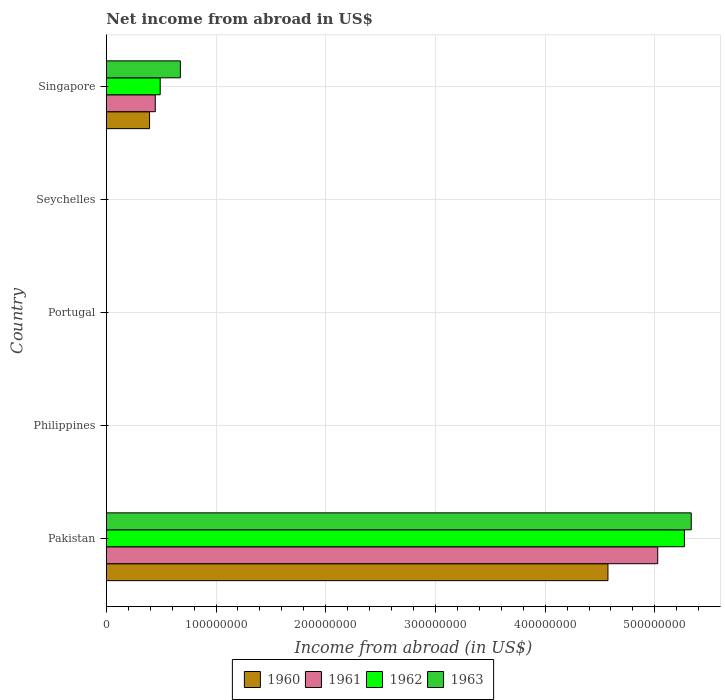Are the number of bars on each tick of the Y-axis equal?
Offer a very short reply. No. How many bars are there on the 4th tick from the top?
Ensure brevity in your answer.  0. What is the net income from abroad in 1962 in Seychelles?
Provide a succinct answer. 0. Across all countries, what is the maximum net income from abroad in 1963?
Your answer should be compact. 5.33e+08. Across all countries, what is the minimum net income from abroad in 1960?
Keep it short and to the point. 0. In which country was the net income from abroad in 1962 maximum?
Offer a very short reply. Pakistan. What is the total net income from abroad in 1961 in the graph?
Offer a very short reply. 5.47e+08. What is the average net income from abroad in 1961 per country?
Ensure brevity in your answer.  1.09e+08. What is the difference between the net income from abroad in 1960 and net income from abroad in 1962 in Pakistan?
Offer a terse response. -6.97e+07. What is the difference between the highest and the lowest net income from abroad in 1961?
Offer a very short reply. 5.03e+08. In how many countries, is the net income from abroad in 1961 greater than the average net income from abroad in 1961 taken over all countries?
Ensure brevity in your answer.  1. Is it the case that in every country, the sum of the net income from abroad in 1963 and net income from abroad in 1960 is greater than the sum of net income from abroad in 1962 and net income from abroad in 1961?
Make the answer very short. No. Is it the case that in every country, the sum of the net income from abroad in 1961 and net income from abroad in 1962 is greater than the net income from abroad in 1963?
Your answer should be compact. No. How many bars are there?
Provide a short and direct response. 8. Are all the bars in the graph horizontal?
Provide a short and direct response. Yes. What is the difference between two consecutive major ticks on the X-axis?
Offer a terse response. 1.00e+08. Does the graph contain any zero values?
Ensure brevity in your answer.  Yes. Does the graph contain grids?
Your response must be concise. Yes. Where does the legend appear in the graph?
Give a very brief answer. Bottom center. How are the legend labels stacked?
Offer a terse response. Horizontal. What is the title of the graph?
Give a very brief answer. Net income from abroad in US$. Does "1971" appear as one of the legend labels in the graph?
Your response must be concise. No. What is the label or title of the X-axis?
Keep it short and to the point. Income from abroad (in US$). What is the Income from abroad (in US$) of 1960 in Pakistan?
Keep it short and to the point. 4.57e+08. What is the Income from abroad (in US$) of 1961 in Pakistan?
Give a very brief answer. 5.03e+08. What is the Income from abroad (in US$) of 1962 in Pakistan?
Keep it short and to the point. 5.27e+08. What is the Income from abroad (in US$) of 1963 in Pakistan?
Your answer should be very brief. 5.33e+08. What is the Income from abroad (in US$) in 1961 in Philippines?
Your response must be concise. 0. What is the Income from abroad (in US$) of 1962 in Philippines?
Your answer should be compact. 0. What is the Income from abroad (in US$) in 1960 in Portugal?
Your answer should be very brief. 0. What is the Income from abroad (in US$) in 1961 in Portugal?
Ensure brevity in your answer.  0. What is the Income from abroad (in US$) in 1960 in Seychelles?
Keep it short and to the point. 0. What is the Income from abroad (in US$) of 1962 in Seychelles?
Offer a very short reply. 0. What is the Income from abroad (in US$) in 1960 in Singapore?
Your answer should be very brief. 3.94e+07. What is the Income from abroad (in US$) of 1961 in Singapore?
Your response must be concise. 4.46e+07. What is the Income from abroad (in US$) of 1962 in Singapore?
Make the answer very short. 4.91e+07. What is the Income from abroad (in US$) of 1963 in Singapore?
Keep it short and to the point. 6.75e+07. Across all countries, what is the maximum Income from abroad (in US$) in 1960?
Give a very brief answer. 4.57e+08. Across all countries, what is the maximum Income from abroad (in US$) of 1961?
Offer a very short reply. 5.03e+08. Across all countries, what is the maximum Income from abroad (in US$) of 1962?
Offer a very short reply. 5.27e+08. Across all countries, what is the maximum Income from abroad (in US$) of 1963?
Offer a terse response. 5.33e+08. Across all countries, what is the minimum Income from abroad (in US$) in 1963?
Offer a terse response. 0. What is the total Income from abroad (in US$) in 1960 in the graph?
Make the answer very short. 4.97e+08. What is the total Income from abroad (in US$) of 1961 in the graph?
Your answer should be very brief. 5.47e+08. What is the total Income from abroad (in US$) in 1962 in the graph?
Your answer should be compact. 5.76e+08. What is the total Income from abroad (in US$) in 1963 in the graph?
Provide a short and direct response. 6.01e+08. What is the difference between the Income from abroad (in US$) of 1960 in Pakistan and that in Singapore?
Give a very brief answer. 4.18e+08. What is the difference between the Income from abroad (in US$) in 1961 in Pakistan and that in Singapore?
Offer a terse response. 4.58e+08. What is the difference between the Income from abroad (in US$) of 1962 in Pakistan and that in Singapore?
Offer a terse response. 4.78e+08. What is the difference between the Income from abroad (in US$) of 1963 in Pakistan and that in Singapore?
Offer a very short reply. 4.66e+08. What is the difference between the Income from abroad (in US$) of 1960 in Pakistan and the Income from abroad (in US$) of 1961 in Singapore?
Offer a very short reply. 4.13e+08. What is the difference between the Income from abroad (in US$) in 1960 in Pakistan and the Income from abroad (in US$) in 1962 in Singapore?
Give a very brief answer. 4.08e+08. What is the difference between the Income from abroad (in US$) of 1960 in Pakistan and the Income from abroad (in US$) of 1963 in Singapore?
Ensure brevity in your answer.  3.90e+08. What is the difference between the Income from abroad (in US$) of 1961 in Pakistan and the Income from abroad (in US$) of 1962 in Singapore?
Your answer should be very brief. 4.54e+08. What is the difference between the Income from abroad (in US$) in 1961 in Pakistan and the Income from abroad (in US$) in 1963 in Singapore?
Offer a terse response. 4.35e+08. What is the difference between the Income from abroad (in US$) of 1962 in Pakistan and the Income from abroad (in US$) of 1963 in Singapore?
Make the answer very short. 4.59e+08. What is the average Income from abroad (in US$) in 1960 per country?
Your answer should be compact. 9.93e+07. What is the average Income from abroad (in US$) in 1961 per country?
Your answer should be very brief. 1.09e+08. What is the average Income from abroad (in US$) of 1962 per country?
Offer a terse response. 1.15e+08. What is the average Income from abroad (in US$) of 1963 per country?
Provide a short and direct response. 1.20e+08. What is the difference between the Income from abroad (in US$) in 1960 and Income from abroad (in US$) in 1961 in Pakistan?
Keep it short and to the point. -4.54e+07. What is the difference between the Income from abroad (in US$) in 1960 and Income from abroad (in US$) in 1962 in Pakistan?
Offer a terse response. -6.97e+07. What is the difference between the Income from abroad (in US$) in 1960 and Income from abroad (in US$) in 1963 in Pakistan?
Keep it short and to the point. -7.59e+07. What is the difference between the Income from abroad (in US$) of 1961 and Income from abroad (in US$) of 1962 in Pakistan?
Provide a succinct answer. -2.43e+07. What is the difference between the Income from abroad (in US$) in 1961 and Income from abroad (in US$) in 1963 in Pakistan?
Offer a terse response. -3.06e+07. What is the difference between the Income from abroad (in US$) in 1962 and Income from abroad (in US$) in 1963 in Pakistan?
Give a very brief answer. -6.23e+06. What is the difference between the Income from abroad (in US$) in 1960 and Income from abroad (in US$) in 1961 in Singapore?
Offer a very short reply. -5.20e+06. What is the difference between the Income from abroad (in US$) in 1960 and Income from abroad (in US$) in 1962 in Singapore?
Provide a short and direct response. -9.70e+06. What is the difference between the Income from abroad (in US$) of 1960 and Income from abroad (in US$) of 1963 in Singapore?
Provide a short and direct response. -2.81e+07. What is the difference between the Income from abroad (in US$) of 1961 and Income from abroad (in US$) of 1962 in Singapore?
Give a very brief answer. -4.50e+06. What is the difference between the Income from abroad (in US$) of 1961 and Income from abroad (in US$) of 1963 in Singapore?
Give a very brief answer. -2.29e+07. What is the difference between the Income from abroad (in US$) of 1962 and Income from abroad (in US$) of 1963 in Singapore?
Offer a terse response. -1.84e+07. What is the ratio of the Income from abroad (in US$) in 1960 in Pakistan to that in Singapore?
Offer a very short reply. 11.61. What is the ratio of the Income from abroad (in US$) in 1961 in Pakistan to that in Singapore?
Keep it short and to the point. 11.27. What is the ratio of the Income from abroad (in US$) of 1962 in Pakistan to that in Singapore?
Ensure brevity in your answer.  10.73. What is the ratio of the Income from abroad (in US$) in 1963 in Pakistan to that in Singapore?
Provide a short and direct response. 7.9. What is the difference between the highest and the lowest Income from abroad (in US$) in 1960?
Your answer should be compact. 4.57e+08. What is the difference between the highest and the lowest Income from abroad (in US$) in 1961?
Give a very brief answer. 5.03e+08. What is the difference between the highest and the lowest Income from abroad (in US$) in 1962?
Your response must be concise. 5.27e+08. What is the difference between the highest and the lowest Income from abroad (in US$) of 1963?
Provide a short and direct response. 5.33e+08. 